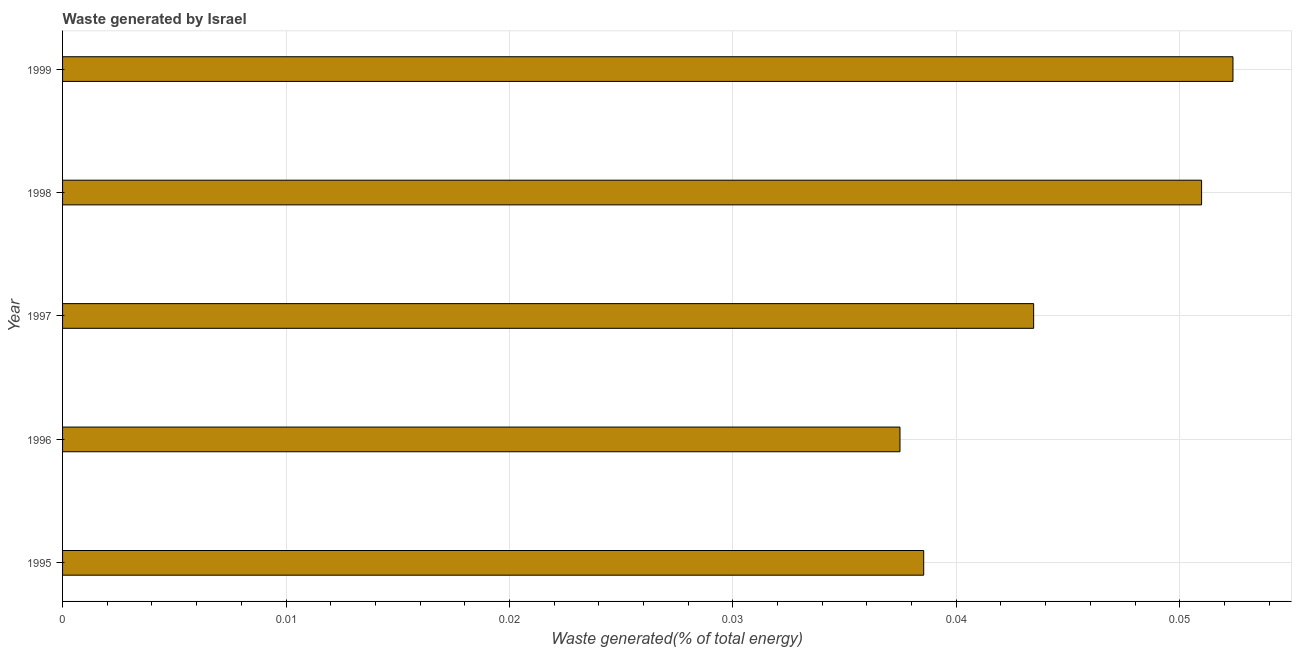Does the graph contain grids?
Keep it short and to the point. Yes. What is the title of the graph?
Offer a very short reply. Waste generated by Israel. What is the label or title of the X-axis?
Offer a very short reply. Waste generated(% of total energy). What is the label or title of the Y-axis?
Make the answer very short. Year. What is the amount of waste generated in 1995?
Offer a very short reply. 0.04. Across all years, what is the maximum amount of waste generated?
Your answer should be very brief. 0.05. Across all years, what is the minimum amount of waste generated?
Offer a terse response. 0.04. What is the sum of the amount of waste generated?
Your response must be concise. 0.22. What is the difference between the amount of waste generated in 1995 and 1998?
Provide a succinct answer. -0.01. What is the average amount of waste generated per year?
Ensure brevity in your answer.  0.04. What is the median amount of waste generated?
Give a very brief answer. 0.04. In how many years, is the amount of waste generated greater than 0.006 %?
Offer a terse response. 5. Do a majority of the years between 1999 and 1998 (inclusive) have amount of waste generated greater than 0.046 %?
Your answer should be compact. No. What is the ratio of the amount of waste generated in 1995 to that in 1999?
Give a very brief answer. 0.74. Is the amount of waste generated in 1996 less than that in 1999?
Provide a short and direct response. Yes. Is the sum of the amount of waste generated in 1998 and 1999 greater than the maximum amount of waste generated across all years?
Keep it short and to the point. Yes. Are all the bars in the graph horizontal?
Your answer should be very brief. Yes. How many years are there in the graph?
Provide a short and direct response. 5. What is the difference between two consecutive major ticks on the X-axis?
Keep it short and to the point. 0.01. What is the Waste generated(% of total energy) in 1995?
Your response must be concise. 0.04. What is the Waste generated(% of total energy) of 1996?
Provide a succinct answer. 0.04. What is the Waste generated(% of total energy) in 1997?
Offer a very short reply. 0.04. What is the Waste generated(% of total energy) in 1998?
Keep it short and to the point. 0.05. What is the Waste generated(% of total energy) in 1999?
Give a very brief answer. 0.05. What is the difference between the Waste generated(% of total energy) in 1995 and 1996?
Your answer should be compact. 0. What is the difference between the Waste generated(% of total energy) in 1995 and 1997?
Offer a very short reply. -0. What is the difference between the Waste generated(% of total energy) in 1995 and 1998?
Offer a very short reply. -0.01. What is the difference between the Waste generated(% of total energy) in 1995 and 1999?
Provide a succinct answer. -0.01. What is the difference between the Waste generated(% of total energy) in 1996 and 1997?
Give a very brief answer. -0.01. What is the difference between the Waste generated(% of total energy) in 1996 and 1998?
Your answer should be very brief. -0.01. What is the difference between the Waste generated(% of total energy) in 1996 and 1999?
Your response must be concise. -0.01. What is the difference between the Waste generated(% of total energy) in 1997 and 1998?
Keep it short and to the point. -0.01. What is the difference between the Waste generated(% of total energy) in 1997 and 1999?
Provide a succinct answer. -0.01. What is the difference between the Waste generated(% of total energy) in 1998 and 1999?
Provide a short and direct response. -0. What is the ratio of the Waste generated(% of total energy) in 1995 to that in 1996?
Your answer should be very brief. 1.03. What is the ratio of the Waste generated(% of total energy) in 1995 to that in 1997?
Give a very brief answer. 0.89. What is the ratio of the Waste generated(% of total energy) in 1995 to that in 1998?
Provide a succinct answer. 0.76. What is the ratio of the Waste generated(% of total energy) in 1995 to that in 1999?
Ensure brevity in your answer.  0.74. What is the ratio of the Waste generated(% of total energy) in 1996 to that in 1997?
Your answer should be compact. 0.86. What is the ratio of the Waste generated(% of total energy) in 1996 to that in 1998?
Make the answer very short. 0.73. What is the ratio of the Waste generated(% of total energy) in 1996 to that in 1999?
Offer a very short reply. 0.71. What is the ratio of the Waste generated(% of total energy) in 1997 to that in 1998?
Your response must be concise. 0.85. What is the ratio of the Waste generated(% of total energy) in 1997 to that in 1999?
Ensure brevity in your answer.  0.83. What is the ratio of the Waste generated(% of total energy) in 1998 to that in 1999?
Provide a short and direct response. 0.97. 